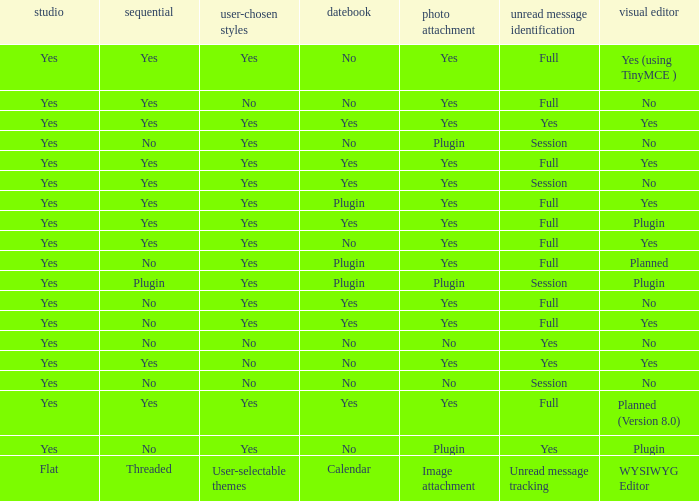Which WYSIWYG Editor has a User-selectable themes of yes, and an Unread message tracking of session, and an Image attachment of plugin? No, Plugin. 